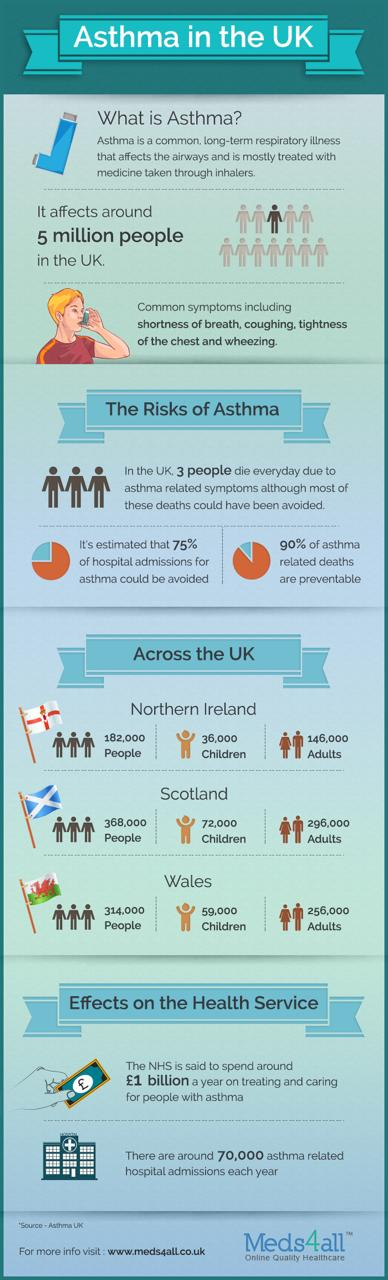Point out several critical features in this image. The infographic lists 3 potential risks of asthma. Approximately 75% of asthma-related hospital issues can be avoided if properly treated. In Scotland, an estimated 72,000 children are suffering from asthma. In Northern Ireland, it is estimated that approximately 146,000 adults suffer from asthma. In Northern Ireland, it is estimated that approximately 36,000 children are suffering from asthma. 